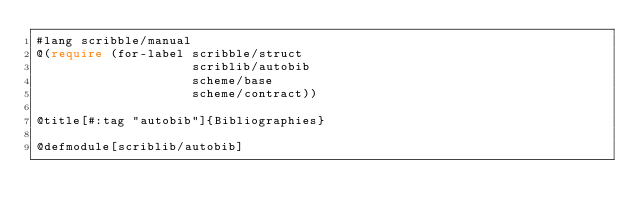<code> <loc_0><loc_0><loc_500><loc_500><_Racket_>#lang scribble/manual
@(require (for-label scribble/struct
                     scriblib/autobib
                     scheme/base
                     scheme/contract))

@title[#:tag "autobib"]{Bibliographies}

@defmodule[scriblib/autobib]
</code> 